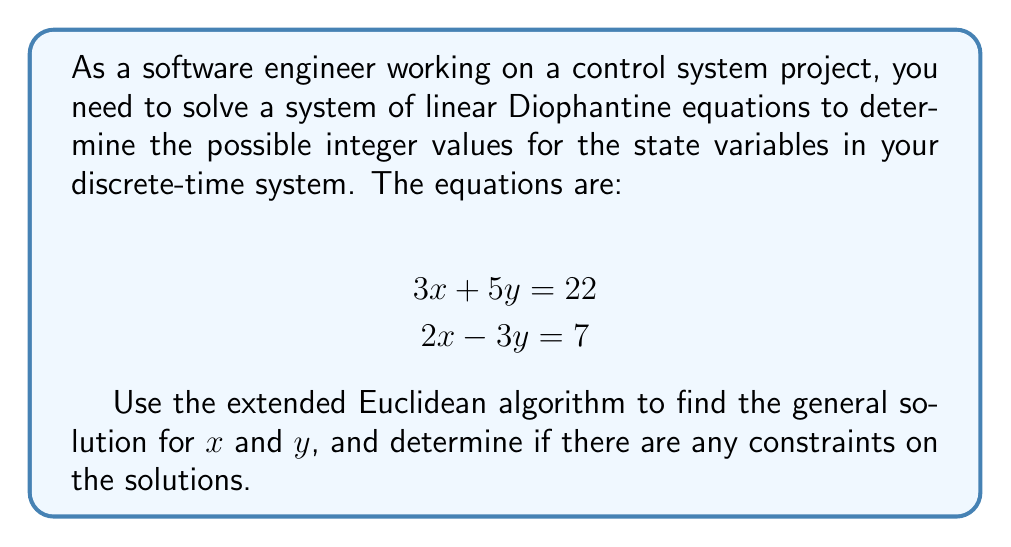Could you help me with this problem? To solve this system of linear Diophantine equations, we'll use the extended Euclidean algorithm and linear algebra techniques.

Step 1: Rewrite the system in matrix form
$$\begin{bmatrix}
3 & 5 \\
2 & -3
\end{bmatrix}
\begin{bmatrix}
x \\
y
\end{bmatrix} =
\begin{bmatrix}
22 \\
7
\end{bmatrix}$$

Step 2: Calculate the determinant of the coefficient matrix
$\det(A) = 3(-3) - 5(2) = -9 - 10 = -19$

Since the determinant is non-zero, there is a unique solution.

Step 3: Use Cramer's rule to find the solution
$$x = \frac{\det(A_x)}{\det(A)} = \frac{22(-3) - 5(7)}{-19} = \frac{-66 - 35}{-19} = \frac{-101}{-19} = \frac{101}{19}$$
$$y = \frac{\det(A_y)}{\det(A)} = \frac{3(7) - 22(2)}{-19} = \frac{21 - 44}{-19} = \frac{-23}{-19} = \frac{23}{19}$$

Step 4: Apply the extended Euclidean algorithm to find integer solutions
We need to solve:
$$19x' = 101 + 19k$$
$$19y' = 23 + 19m$$

Using the extended Euclidean algorithm for 19 and 101:
$101 = 5 \cdot 19 + 6$
$19 = 3 \cdot 6 + 1$
$6 = 6 \cdot 1 + 0$

Working backwards:
$1 = 19 - 3 \cdot 6$
$1 = 19 - 3 \cdot (101 - 5 \cdot 19) = 16 \cdot 19 - 3 \cdot 101$

Therefore, $x' = 16 + 19k$ and $y' = 4 + 19m$ (for the second equation).

Step 5: Express the general solution
The general solution is:
$$x = 16 + 19k$$
$$y = 4 + 19m$$

where $k$ and $m$ are integers.

Step 6: Verify the solution
Substituting the general solution into the original equations:
$3(16 + 19k) + 5(4 + 19m) = 48 + 57k + 20 + 95m = 68 + 57k + 95m$
$2(16 + 19k) - 3(4 + 19m) = 32 + 38k - 12 - 57m = 20 + 38k - 57m$

For the first equation to be true: $68 + 57k + 95m = 22$, which implies $57k + 95m = -46$
For the second equation to be true: $20 + 38k - 57m = 7$, which implies $38k - 57m = -13$

These equations are always satisfied for integer $k$ and $m$, confirming that our general solution is correct.
Answer: The general solution to the system of linear Diophantine equations is:

$$x = 16 + 19k$$
$$y = 4 + 19m$$

where $k$ and $m$ are integers. There are no additional constraints on the solutions beyond $k$ and $m$ being integers. 